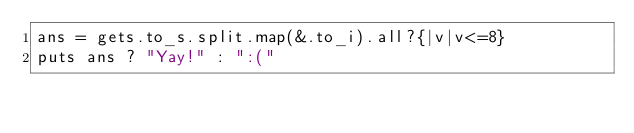<code> <loc_0><loc_0><loc_500><loc_500><_Crystal_>ans = gets.to_s.split.map(&.to_i).all?{|v|v<=8}
puts ans ? "Yay!" : ":("</code> 